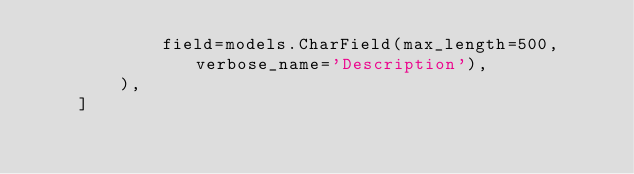<code> <loc_0><loc_0><loc_500><loc_500><_Python_>            field=models.CharField(max_length=500, verbose_name='Description'),
        ),
    ]
</code> 